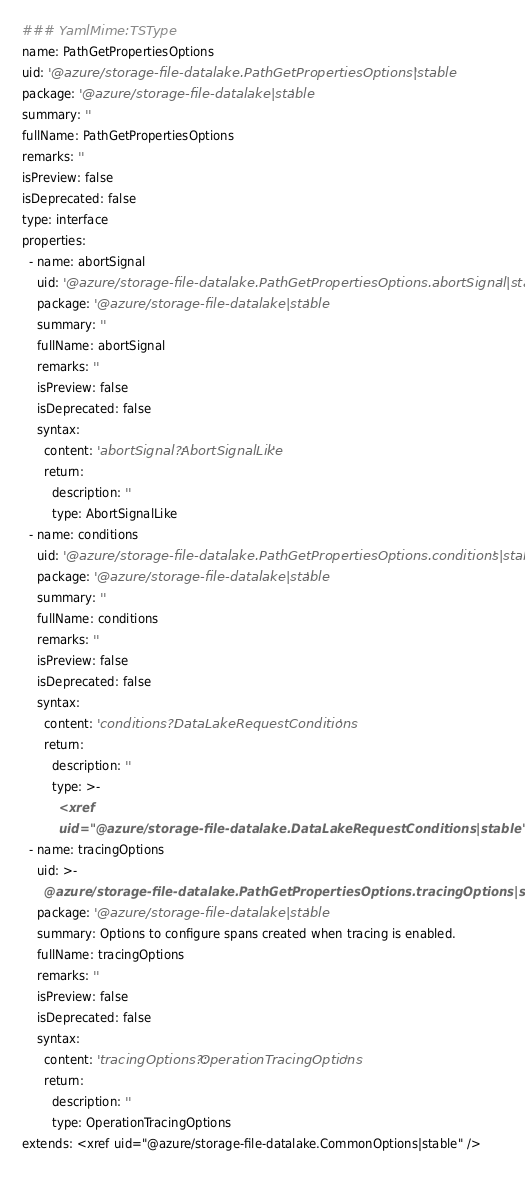Convert code to text. <code><loc_0><loc_0><loc_500><loc_500><_YAML_>### YamlMime:TSType
name: PathGetPropertiesOptions
uid: '@azure/storage-file-datalake.PathGetPropertiesOptions|stable'
package: '@azure/storage-file-datalake|stable'
summary: ''
fullName: PathGetPropertiesOptions
remarks: ''
isPreview: false
isDeprecated: false
type: interface
properties:
  - name: abortSignal
    uid: '@azure/storage-file-datalake.PathGetPropertiesOptions.abortSignal|stable'
    package: '@azure/storage-file-datalake|stable'
    summary: ''
    fullName: abortSignal
    remarks: ''
    isPreview: false
    isDeprecated: false
    syntax:
      content: 'abortSignal?: AbortSignalLike'
      return:
        description: ''
        type: AbortSignalLike
  - name: conditions
    uid: '@azure/storage-file-datalake.PathGetPropertiesOptions.conditions|stable'
    package: '@azure/storage-file-datalake|stable'
    summary: ''
    fullName: conditions
    remarks: ''
    isPreview: false
    isDeprecated: false
    syntax:
      content: 'conditions?: DataLakeRequestConditions'
      return:
        description: ''
        type: >-
          <xref
          uid="@azure/storage-file-datalake.DataLakeRequestConditions|stable" />
  - name: tracingOptions
    uid: >-
      @azure/storage-file-datalake.PathGetPropertiesOptions.tracingOptions|stable
    package: '@azure/storage-file-datalake|stable'
    summary: Options to configure spans created when tracing is enabled.
    fullName: tracingOptions
    remarks: ''
    isPreview: false
    isDeprecated: false
    syntax:
      content: 'tracingOptions?: OperationTracingOptions'
      return:
        description: ''
        type: OperationTracingOptions
extends: <xref uid="@azure/storage-file-datalake.CommonOptions|stable" />
</code> 